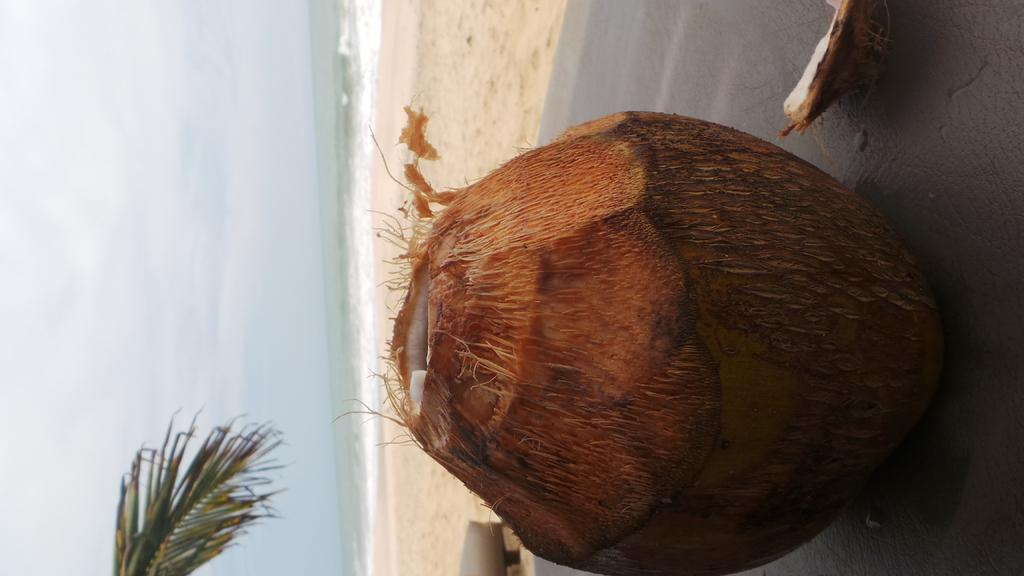What is the main object in the image? There is a coconut in the image. What can be seen in the background of the image? Water and the sky are visible in the background of the image. What type of chain can be seen hanging from the coconut in the image? There is no chain present in the image; it only features a coconut. What is the source of shame in the image? There is no indication of shame in the image, as it only contains a coconut and the background. 